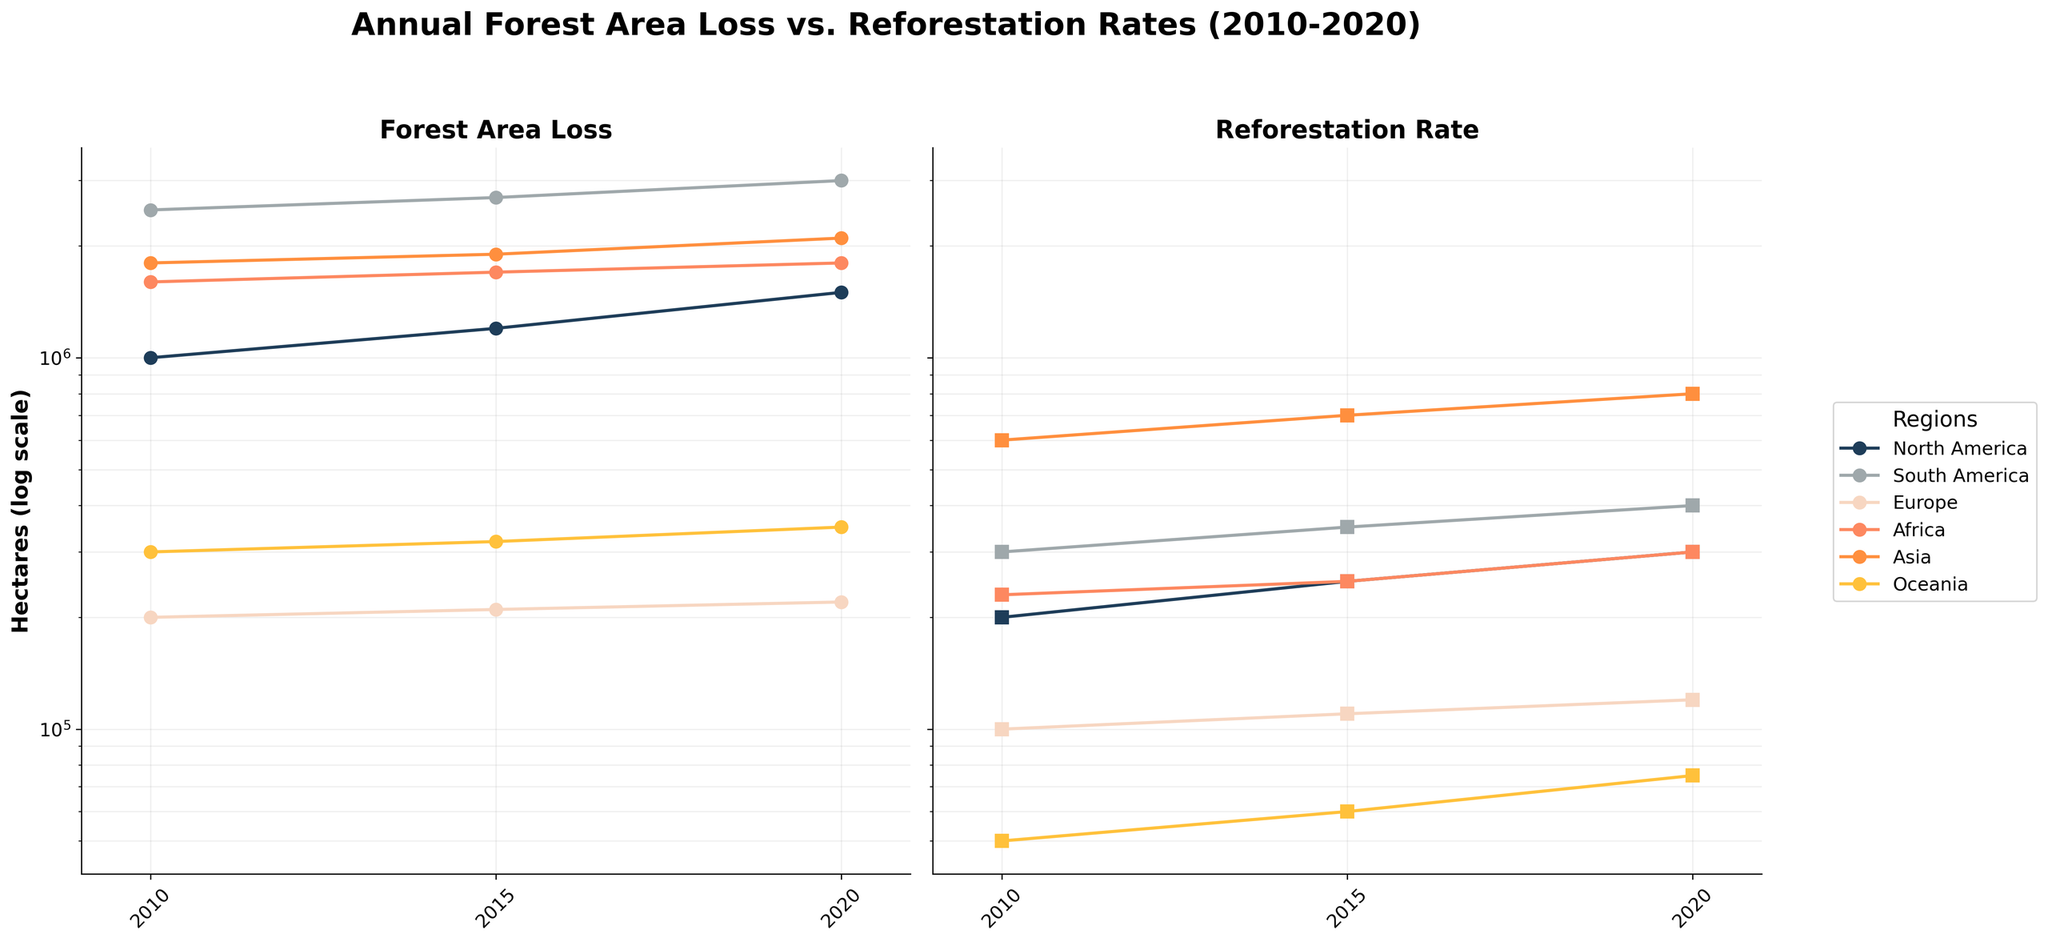How many different regions are visualized in the plot? The labels on the legend indicate the number of different regions represented. The figure shows a legend with the regions North America, South America, Europe, Africa, Asia, and Oceania.
Answer: 6 Which region has the highest forest area loss in 2020? By examining the left subplot for the year 2020, the highest data point is for South America.
Answer: South America How do reforestation rates in Europe compare with Africa in 2020? Compare the points for the year 2020 in the right subplot. Europe has a reforestation rate of 120,000 hectares while Africa has 300,000 hectares.
Answer: Africa is higher Which region shows the greatest increase in forest area loss from 2010 to 2020? By observing the changes in the left subplot, the region with the largest increase (steepest slope) between 2010 and 2020 is North America (from 1,000,000 to 1,500,000 hectares).
Answer: North America What is the trend in reforestation rates for Asia from 2010 to 2020? In the right subplot, note that the data points for Asia increase steadily from 600,000 hectares in 2010 to 800,000 hectares in 2020.
Answer: Increasing Which regions had a higher reforestation rate than forest area loss in 2010? Compare the left and right subplots for 2010. Only Asia (with reforestation rate of 600,000 hectares) had a higher value compared to its forest area loss (1,800,000 hectares), but Africa had the closest ratio with only little disparity.
Answer: None Is the forest area loss logarithmically scaled, and if so, why? The y-axis in both subplots is in a logarithmic scale, indicated by the "log scale" label to better represent the data's wide range and to observe trends more clearly.
Answer: Yes, to represent data's wide range What is the trend in forest area loss in Oceania from 2010 to 2020? The points in the left subplot for Oceania show values increasing steadily from 300,000 hectares in 2010 to 350,000 hectares in 2020.
Answer: Increasing How does the forest area loss in North America in 2015 compare to the reforestation rate in Asia in the same year? Compare the 2015 data points in both subplots. North America's forest area loss is 1,200,000 hectares, while Asia's reforestation rate is 700,000 hectares.
Answer: North America is greater 